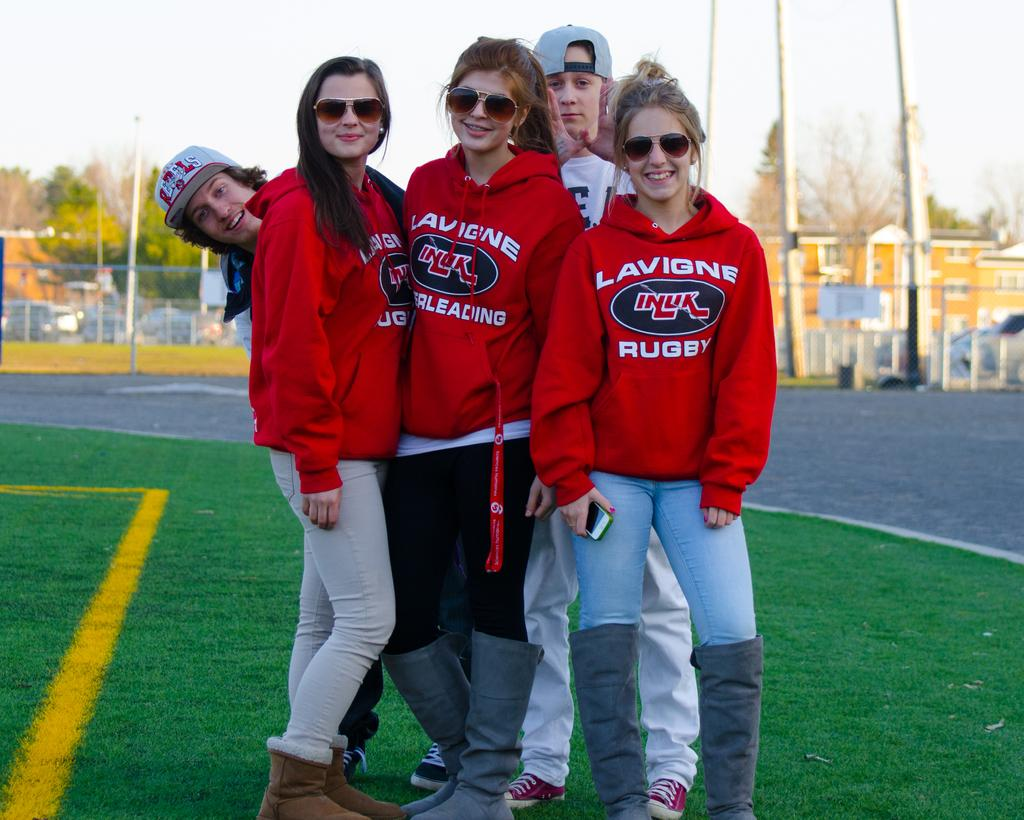<image>
Describe the image concisely. A group of people with red sweatshirts that say Lavigne Rugby. 